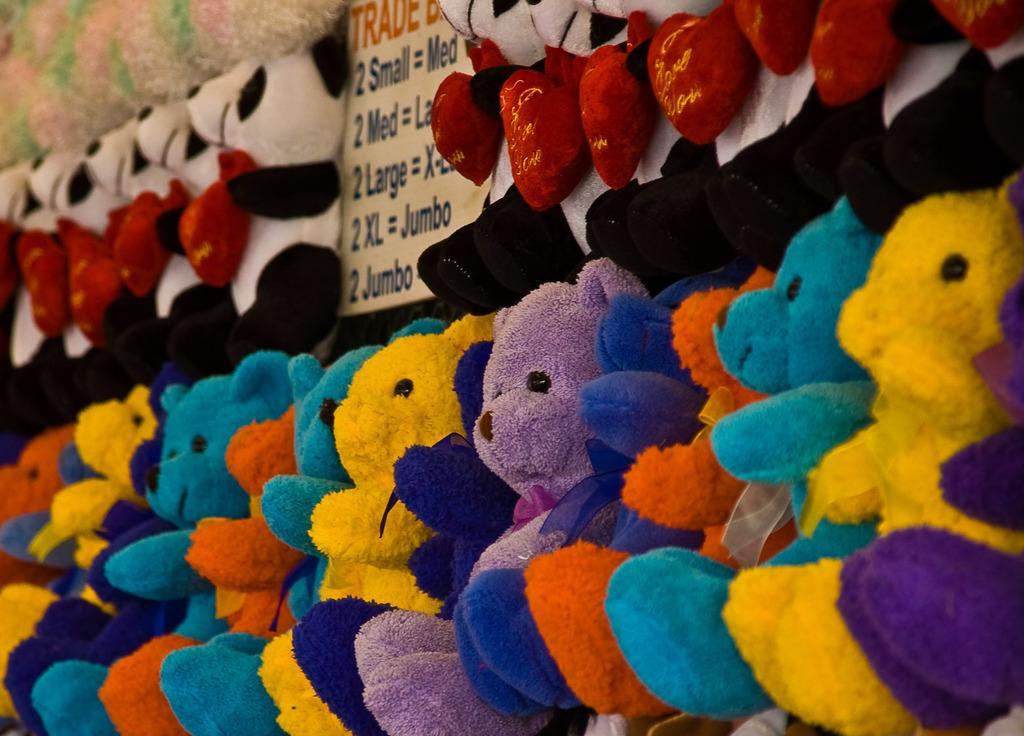Can you describe this image briefly? As we can see in the image there are different colors of teddy bear dolls and there is a banner. 